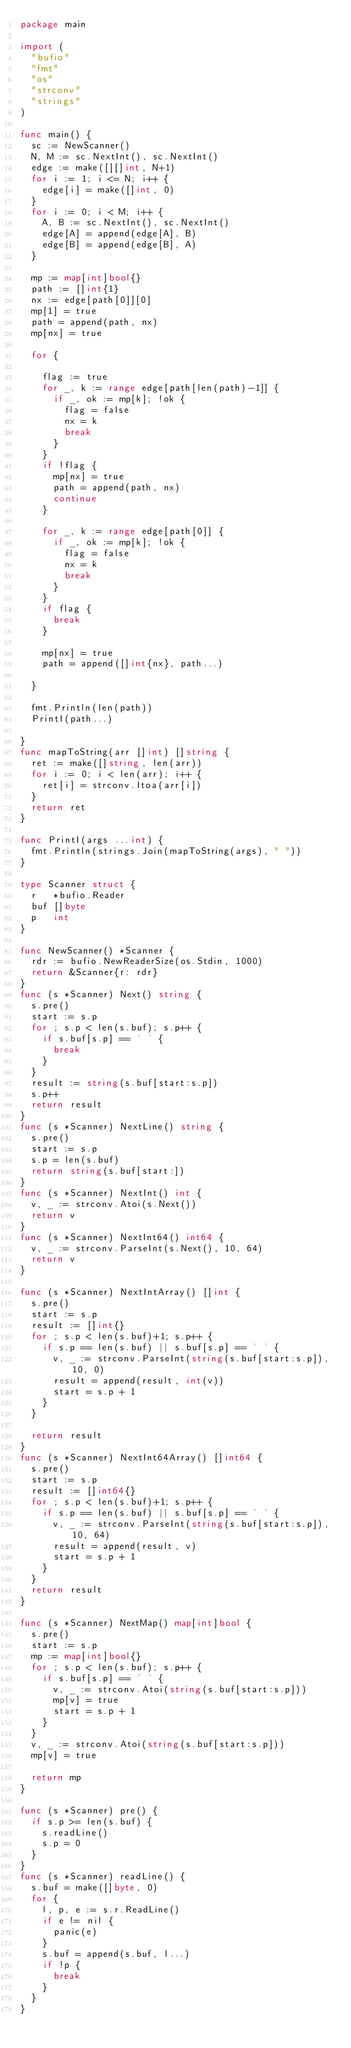Convert code to text. <code><loc_0><loc_0><loc_500><loc_500><_Go_>package main

import (
	"bufio"
	"fmt"
	"os"
	"strconv"
	"strings"
)

func main() {
	sc := NewScanner()
	N, M := sc.NextInt(), sc.NextInt()
	edge := make([][]int, N+1)
	for i := 1; i <= N; i++ {
		edge[i] = make([]int, 0)
	}
	for i := 0; i < M; i++ {
		A, B := sc.NextInt(), sc.NextInt()
		edge[A] = append(edge[A], B)
		edge[B] = append(edge[B], A)
	}

	mp := map[int]bool{}
	path := []int{1}
	nx := edge[path[0]][0]
	mp[1] = true
	path = append(path, nx)
	mp[nx] = true

	for {

		flag := true
		for _, k := range edge[path[len(path)-1]] {
			if _, ok := mp[k]; !ok {
				flag = false
				nx = k
				break
			}
		}
		if !flag {
			mp[nx] = true
			path = append(path, nx)
			continue
		}

		for _, k := range edge[path[0]] {
			if _, ok := mp[k]; !ok {
				flag = false
				nx = k
				break
			}
		}
		if flag {
			break
		}

		mp[nx] = true
		path = append([]int{nx}, path...)

	}

	fmt.Println(len(path))
	PrintI(path...)

}
func mapToString(arr []int) []string {
	ret := make([]string, len(arr))
	for i := 0; i < len(arr); i++ {
		ret[i] = strconv.Itoa(arr[i])
	}
	return ret
}

func PrintI(args ...int) {
	fmt.Println(strings.Join(mapToString(args), " "))
}

type Scanner struct {
	r   *bufio.Reader
	buf []byte
	p   int
}

func NewScanner() *Scanner {
	rdr := bufio.NewReaderSize(os.Stdin, 1000)
	return &Scanner{r: rdr}
}
func (s *Scanner) Next() string {
	s.pre()
	start := s.p
	for ; s.p < len(s.buf); s.p++ {
		if s.buf[s.p] == ' ' {
			break
		}
	}
	result := string(s.buf[start:s.p])
	s.p++
	return result
}
func (s *Scanner) NextLine() string {
	s.pre()
	start := s.p
	s.p = len(s.buf)
	return string(s.buf[start:])
}
func (s *Scanner) NextInt() int {
	v, _ := strconv.Atoi(s.Next())
	return v
}
func (s *Scanner) NextInt64() int64 {
	v, _ := strconv.ParseInt(s.Next(), 10, 64)
	return v
}

func (s *Scanner) NextIntArray() []int {
	s.pre()
	start := s.p
	result := []int{}
	for ; s.p < len(s.buf)+1; s.p++ {
		if s.p == len(s.buf) || s.buf[s.p] == ' ' {
			v, _ := strconv.ParseInt(string(s.buf[start:s.p]), 10, 0)
			result = append(result, int(v))
			start = s.p + 1
		}
	}

	return result
}
func (s *Scanner) NextInt64Array() []int64 {
	s.pre()
	start := s.p
	result := []int64{}
	for ; s.p < len(s.buf)+1; s.p++ {
		if s.p == len(s.buf) || s.buf[s.p] == ' ' {
			v, _ := strconv.ParseInt(string(s.buf[start:s.p]), 10, 64)
			result = append(result, v)
			start = s.p + 1
		}
	}
	return result
}

func (s *Scanner) NextMap() map[int]bool {
	s.pre()
	start := s.p
	mp := map[int]bool{}
	for ; s.p < len(s.buf); s.p++ {
		if s.buf[s.p] == ' ' {
			v, _ := strconv.Atoi(string(s.buf[start:s.p]))
			mp[v] = true
			start = s.p + 1
		}
	}
	v, _ := strconv.Atoi(string(s.buf[start:s.p]))
	mp[v] = true

	return mp
}

func (s *Scanner) pre() {
	if s.p >= len(s.buf) {
		s.readLine()
		s.p = 0
	}
}
func (s *Scanner) readLine() {
	s.buf = make([]byte, 0)
	for {
		l, p, e := s.r.ReadLine()
		if e != nil {
			panic(e)
		}
		s.buf = append(s.buf, l...)
		if !p {
			break
		}
	}
}
</code> 